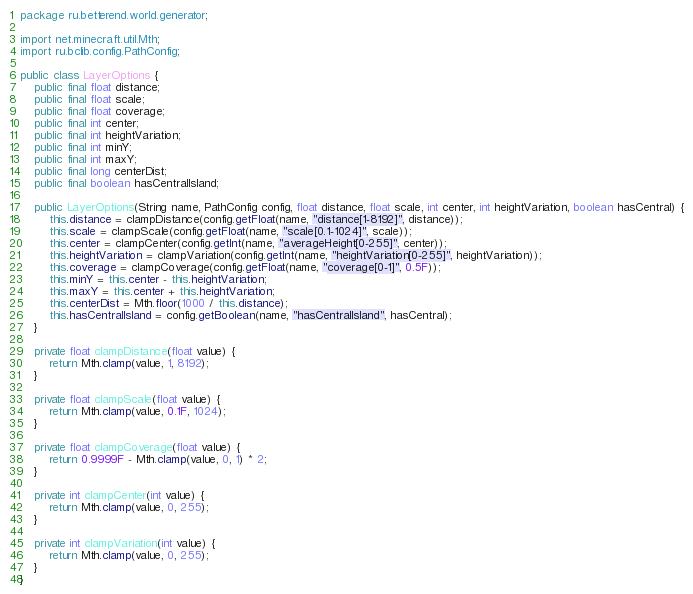<code> <loc_0><loc_0><loc_500><loc_500><_Java_>package ru.betterend.world.generator;

import net.minecraft.util.Mth;
import ru.bclib.config.PathConfig;

public class LayerOptions {
	public final float distance;
	public final float scale;
	public final float coverage;
	public final int center;
	public final int heightVariation;
	public final int minY;
	public final int maxY;
	public final long centerDist;
	public final boolean hasCentralIsland;
	
	public LayerOptions(String name, PathConfig config, float distance, float scale, int center, int heightVariation, boolean hasCentral) {
		this.distance = clampDistance(config.getFloat(name, "distance[1-8192]", distance));
		this.scale = clampScale(config.getFloat(name, "scale[0.1-1024]", scale));
		this.center = clampCenter(config.getInt(name, "averageHeight[0-255]", center));
		this.heightVariation = clampVariation(config.getInt(name, "heightVariation[0-255]", heightVariation));
		this.coverage = clampCoverage(config.getFloat(name, "coverage[0-1]", 0.5F));
		this.minY = this.center - this.heightVariation;
		this.maxY = this.center + this.heightVariation;
		this.centerDist = Mth.floor(1000 / this.distance);
		this.hasCentralIsland = config.getBoolean(name, "hasCentralIsland", hasCentral);
	}
	
	private float clampDistance(float value) {
		return Mth.clamp(value, 1, 8192);
	}
	
	private float clampScale(float value) {
		return Mth.clamp(value, 0.1F, 1024);
	}
	
	private float clampCoverage(float value) {
		return 0.9999F - Mth.clamp(value, 0, 1) * 2;
	}
	
	private int clampCenter(int value) {
		return Mth.clamp(value, 0, 255);
	}
	
	private int clampVariation(int value) {
		return Mth.clamp(value, 0, 255);
	}
}
</code> 